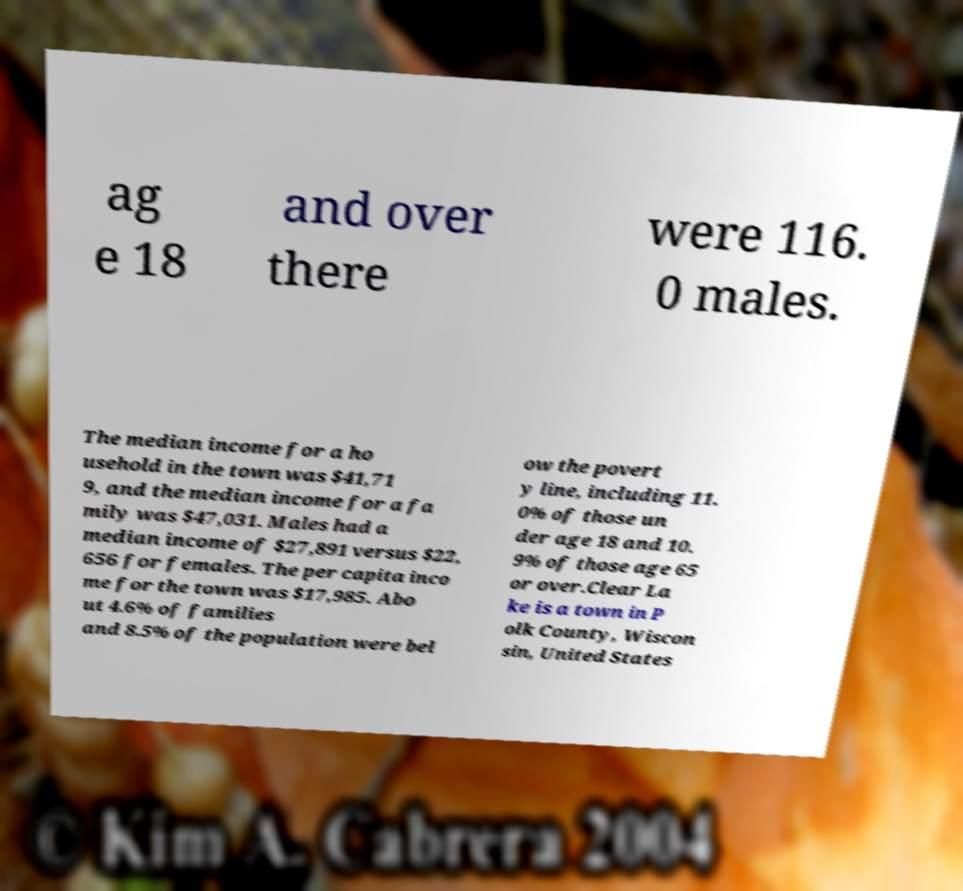Could you assist in decoding the text presented in this image and type it out clearly? ag e 18 and over there were 116. 0 males. The median income for a ho usehold in the town was $41,71 9, and the median income for a fa mily was $47,031. Males had a median income of $27,891 versus $22, 656 for females. The per capita inco me for the town was $17,985. Abo ut 4.6% of families and 8.5% of the population were bel ow the povert y line, including 11. 0% of those un der age 18 and 10. 9% of those age 65 or over.Clear La ke is a town in P olk County, Wiscon sin, United States 